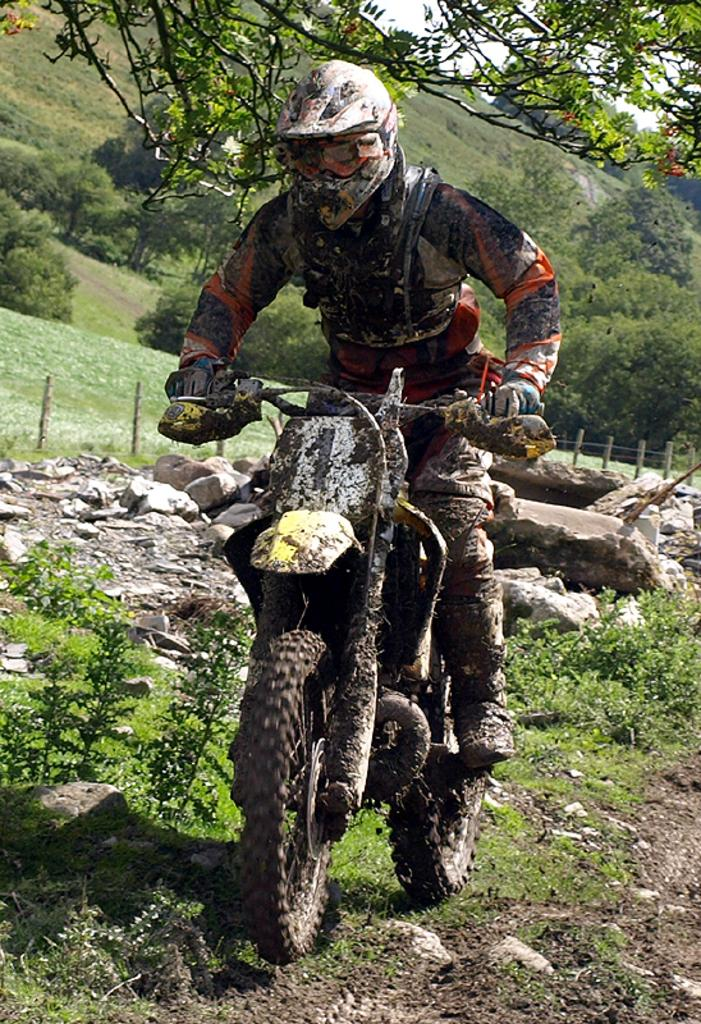Who or what is the main subject in the image? There is a person in the image. What is the person wearing? The person is wearing a jersey. What activity is the person engaged in? The person is riding a bike. What type of natural environment can be seen in the image? There are trees visible in the image. What type of prose is the person reading while riding the bike in the image? There is no indication in the image that the person is reading any prose while riding the bike. 